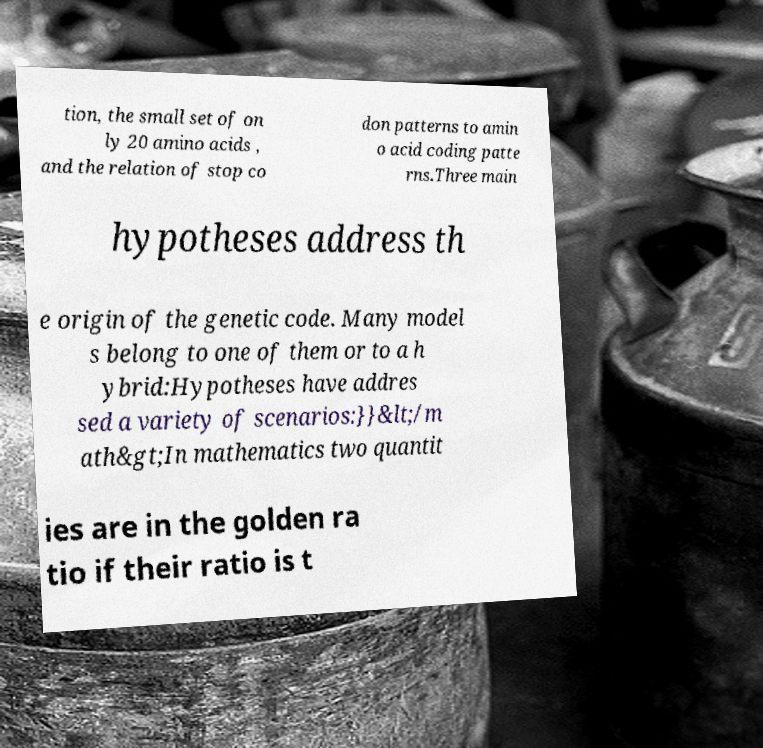Please identify and transcribe the text found in this image. tion, the small set of on ly 20 amino acids , and the relation of stop co don patterns to amin o acid coding patte rns.Three main hypotheses address th e origin of the genetic code. Many model s belong to one of them or to a h ybrid:Hypotheses have addres sed a variety of scenarios:}}&lt;/m ath&gt;In mathematics two quantit ies are in the golden ra tio if their ratio is t 